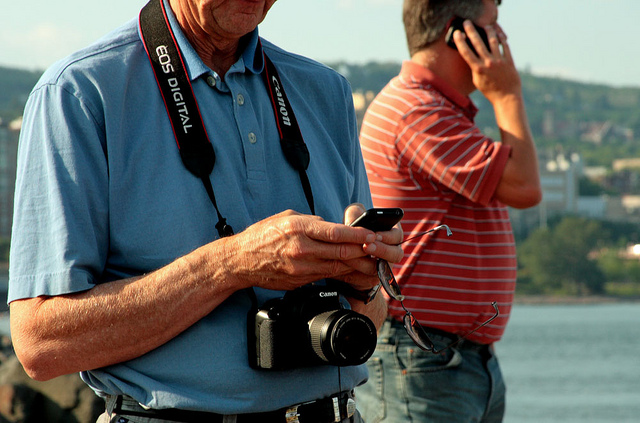Identify the text contained in this image. EOS DIGITAL CANON Canon 